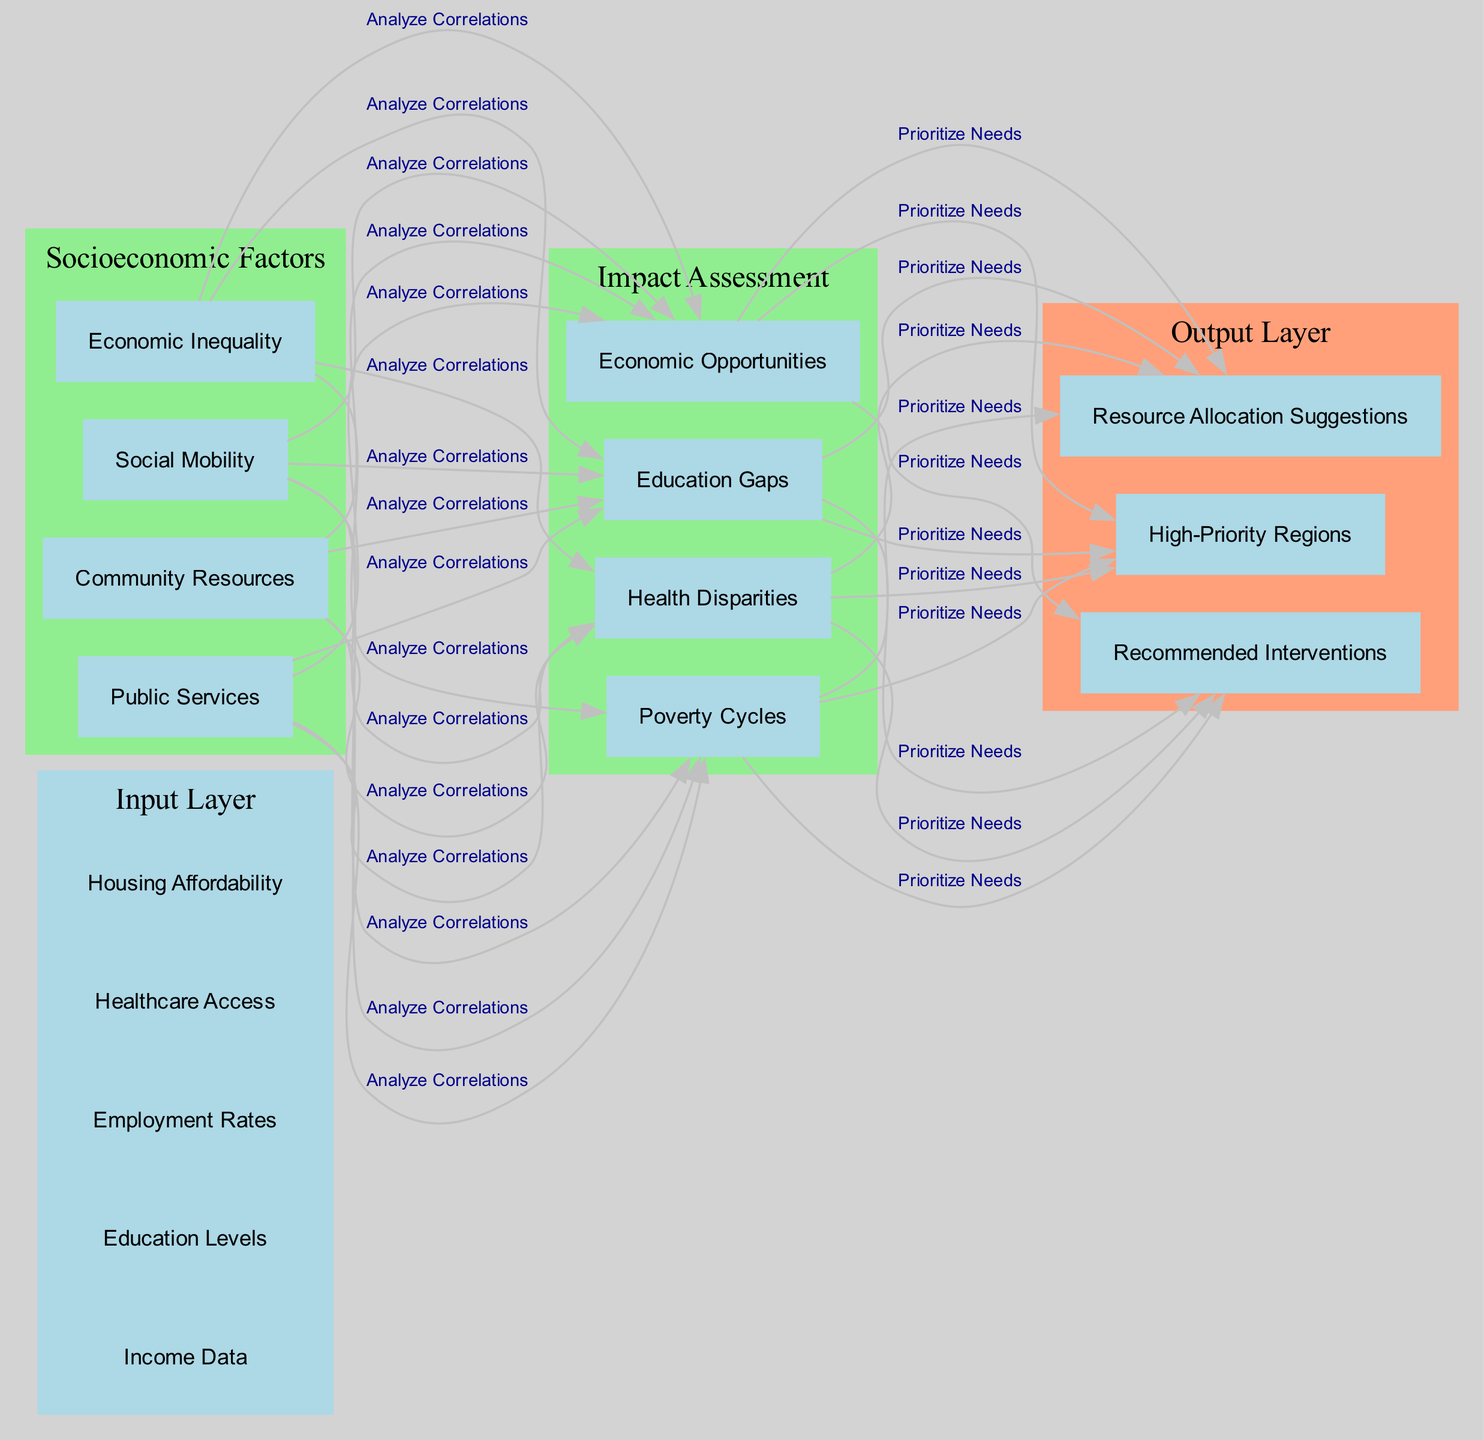What are the input nodes in this neural network? The input layer consists of five nodes: Income Data, Education Levels, Employment Rates, Healthcare Access, and Housing Affordability.
Answer: Income Data, Education Levels, Employment Rates, Healthcare Access, Housing Affordability How many nodes are in the "Impact Assessment" hidden layer? The "Impact Assessment" hidden layer contains four nodes: Poverty Cycles, Education Gaps, Health Disparities, and Economic Opportunities.
Answer: 4 What is the connection label from "Socioeconomic Factors" to "Impact Assessment"? The connection from "Socioeconomic Factors" to "Impact Assessment" is labeled "Analyze Correlations", indicating the nature of the relationship between these layers.
Answer: Analyze Correlations What are the output nodes of this neural network? The output layer consists of three nodes: High-Priority Regions, Recommended Interventions, and Resource Allocation Suggestions, which represent the results of the analysis.
Answer: High-Priority Regions, Recommended Interventions, Resource Allocation Suggestions Which hidden layer has a node named "Community Resources"? The node "Community Resources" is located in the hidden layer named "Socioeconomic Factors", which suggests its relevance to the socioeconomic influences on the data analyzed.
Answer: Socioeconomic Factors What is the flow of information from the input layer to the output layer? The flow begins with input data feeding into the "Socioeconomic Factors" hidden layer, analyzing correlations, followed by its connection to the "Impact Assessment" layer, which then prioritizes needs and outputs three specific recommendations.
Answer: Income Data to Socioeconomic Factors to Impact Assessment to Output Layer What does "Poverty Cycles" connect to in the output layer? "Poverty Cycles" from the "Impact Assessment" layer connects to the output layer, but specifically it flows toward the prioritization of needs, indicating its importance in determining high-priority interventions.
Answer: High-Priority Regions, Recommended Interventions, Resource Allocation Suggestions How many connections are depicted in the diagram? There are a total of two connections illustrated, one from "Socioeconomic Factors" to "Impact Assessment" and one from "Impact Assessment" to the output layer, indicating how the layers interact in the analysis process.
Answer: 2 Which socioeconomic factor is primarily related to "Healthcare Access"? "Healthcare Access" is primarily related to "Economic Inequality" within the "Socioeconomic Factors" hidden layer, as it highlights a correlation crucial for assessing overall socioeconomic conditions.
Answer: Economic Inequality 